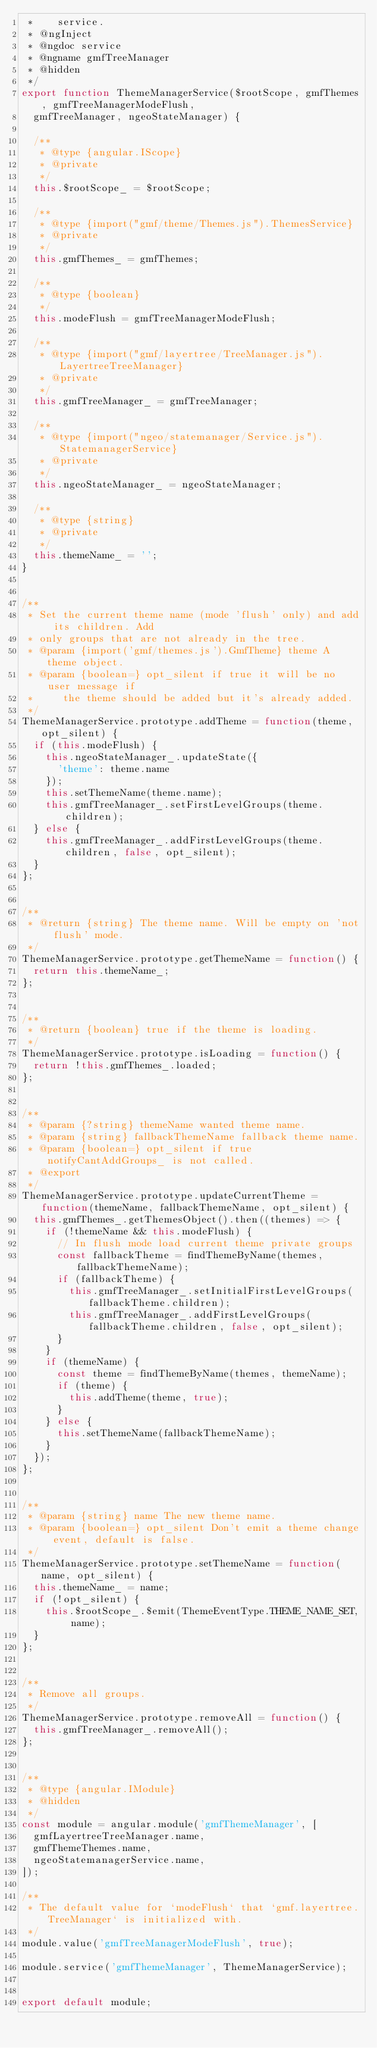<code> <loc_0><loc_0><loc_500><loc_500><_JavaScript_> *    service.
 * @ngInject
 * @ngdoc service
 * @ngname gmfTreeManager
 * @hidden
 */
export function ThemeManagerService($rootScope, gmfThemes, gmfTreeManagerModeFlush,
  gmfTreeManager, ngeoStateManager) {

  /**
   * @type {angular.IScope}
   * @private
   */
  this.$rootScope_ = $rootScope;

  /**
   * @type {import("gmf/theme/Themes.js").ThemesService}
   * @private
   */
  this.gmfThemes_ = gmfThemes;

  /**
   * @type {boolean}
   */
  this.modeFlush = gmfTreeManagerModeFlush;

  /**
   * @type {import("gmf/layertree/TreeManager.js").LayertreeTreeManager}
   * @private
   */
  this.gmfTreeManager_ = gmfTreeManager;

  /**
   * @type {import("ngeo/statemanager/Service.js").StatemanagerService}
   * @private
   */
  this.ngeoStateManager_ = ngeoStateManager;

  /**
   * @type {string}
   * @private
   */
  this.themeName_ = '';
}


/**
 * Set the current theme name (mode 'flush' only) and add its children. Add
 * only groups that are not already in the tree.
 * @param {import('gmf/themes.js').GmfTheme} theme A theme object.
 * @param {boolean=} opt_silent if true it will be no user message if
 *     the theme should be added but it's already added.
 */
ThemeManagerService.prototype.addTheme = function(theme, opt_silent) {
  if (this.modeFlush) {
    this.ngeoStateManager_.updateState({
      'theme': theme.name
    });
    this.setThemeName(theme.name);
    this.gmfTreeManager_.setFirstLevelGroups(theme.children);
  } else {
    this.gmfTreeManager_.addFirstLevelGroups(theme.children, false, opt_silent);
  }
};


/**
 * @return {string} The theme name. Will be empty on 'not flush' mode.
 */
ThemeManagerService.prototype.getThemeName = function() {
  return this.themeName_;
};


/**
 * @return {boolean} true if the theme is loading.
 */
ThemeManagerService.prototype.isLoading = function() {
  return !this.gmfThemes_.loaded;
};


/**
 * @param {?string} themeName wanted theme name.
 * @param {string} fallbackThemeName fallback theme name.
 * @param {boolean=} opt_silent if true notifyCantAddGroups_ is not called.
 * @export
 */
ThemeManagerService.prototype.updateCurrentTheme = function(themeName, fallbackThemeName, opt_silent) {
  this.gmfThemes_.getThemesObject().then((themes) => {
    if (!themeName && this.modeFlush) {
      // In flush mode load current theme private groups
      const fallbackTheme = findThemeByName(themes, fallbackThemeName);
      if (fallbackTheme) {
        this.gmfTreeManager_.setInitialFirstLevelGroups(fallbackTheme.children);
        this.gmfTreeManager_.addFirstLevelGroups(fallbackTheme.children, false, opt_silent);
      }
    }
    if (themeName) {
      const theme = findThemeByName(themes, themeName);
      if (theme) {
        this.addTheme(theme, true);
      }
    } else {
      this.setThemeName(fallbackThemeName);
    }
  });
};


/**
 * @param {string} name The new theme name.
 * @param {boolean=} opt_silent Don't emit a theme change event, default is false.
 */
ThemeManagerService.prototype.setThemeName = function(name, opt_silent) {
  this.themeName_ = name;
  if (!opt_silent) {
    this.$rootScope_.$emit(ThemeEventType.THEME_NAME_SET, name);
  }
};


/**
 * Remove all groups.
 */
ThemeManagerService.prototype.removeAll = function() {
  this.gmfTreeManager_.removeAll();
};


/**
 * @type {angular.IModule}
 * @hidden
 */
const module = angular.module('gmfThemeManager', [
  gmfLayertreeTreeManager.name,
  gmfThemeThemes.name,
  ngeoStatemanagerService.name,
]);

/**
 * The default value for `modeFlush` that `gmf.layertree.TreeManager` is initialized with.
 */
module.value('gmfTreeManagerModeFlush', true);

module.service('gmfThemeManager', ThemeManagerService);


export default module;
</code> 